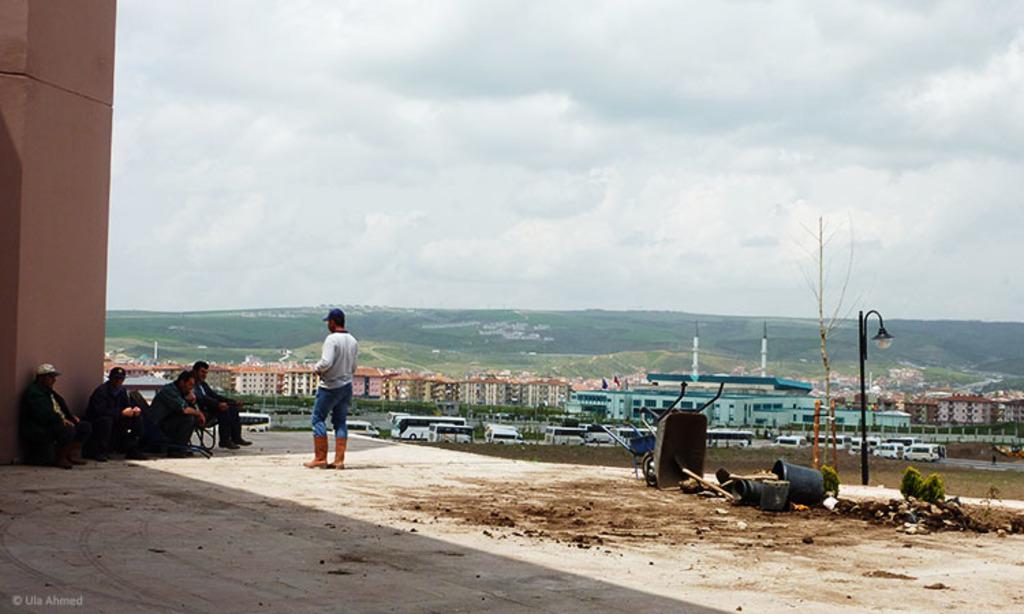Describe this image in one or two sentences. In this picture in the center there are persons sitting and there is a person standing, there are stones and there are buckets on the ground and there is a trolley, there is a light pole which is black in colour. On the left side there is a wall. In the background there are vehicles, buildings, poles, there's grass on the ground and there are mountains and the sky is cloudy. 